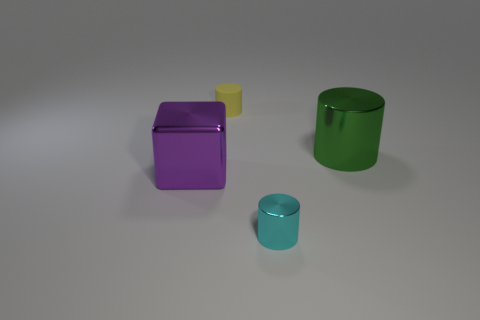What size is the other rubber thing that is the same shape as the small cyan object?
Make the answer very short. Small. Are there any other things that are the same size as the cube?
Keep it short and to the point. Yes. Are there an equal number of cyan cylinders that are to the right of the small shiny thing and tiny cyan metal cylinders behind the large metal block?
Ensure brevity in your answer.  Yes. Is the size of the metal cylinder that is in front of the purple block the same as the shiny thing left of the small yellow matte cylinder?
Offer a very short reply. No. There is a thing that is to the left of the cyan object and behind the purple cube; what is its material?
Make the answer very short. Rubber. Is the number of small blue rubber blocks less than the number of green objects?
Make the answer very short. Yes. There is a cylinder that is in front of the large purple shiny block that is behind the small cyan metal cylinder; how big is it?
Keep it short and to the point. Small. What is the shape of the metal thing to the left of the cylinder in front of the large thing that is right of the matte object?
Your answer should be very brief. Cube. There is a block that is the same material as the green object; what is its color?
Provide a short and direct response. Purple. What is the color of the large metal thing to the left of the object in front of the large object that is left of the yellow rubber cylinder?
Ensure brevity in your answer.  Purple. 